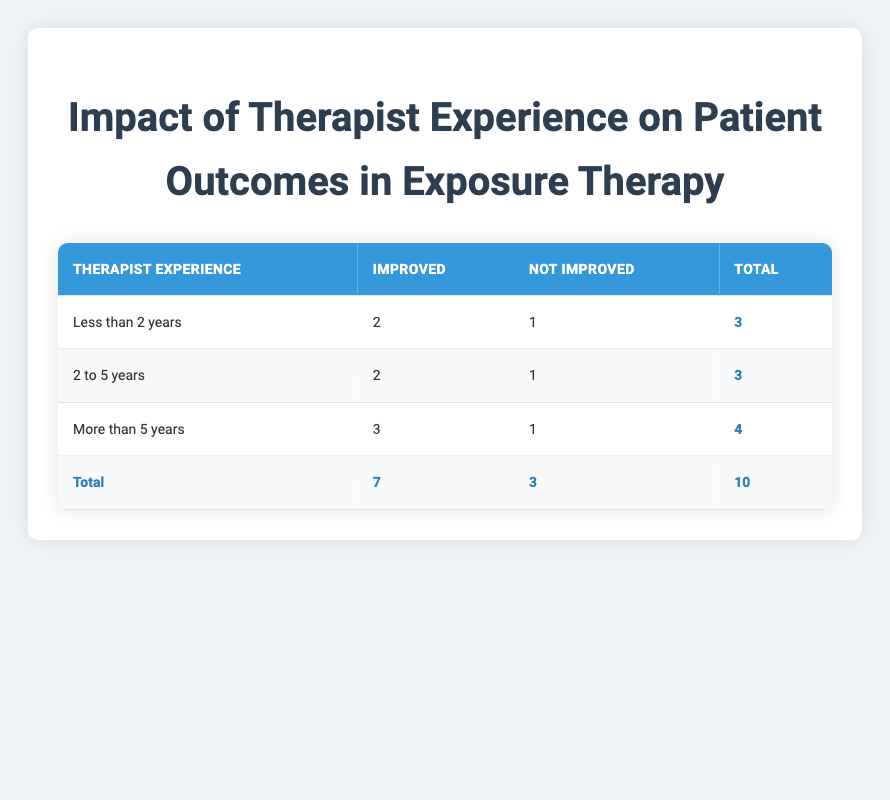What is the total number of patients treated by therapists with less than 2 years of experience? From the table, for therapists with less than 2 years of experience, there are 2 Improved outcomes and 1 Not Improved outcome. Adding these gives a total of 2 + 1 = 3 patients.
Answer: 3 How many patients improved when treated by therapists with more than 5 years of experience? The table shows that for therapists with more than 5 years of experience, there are 3 Improved outcomes. Therefore, the number of patients who improved is 3.
Answer: 3 What is the ratio of Improved to Not Improved outcomes for therapists with 2 to 5 years of experience? According to the table, therapists with 2 to 5 years of experience have 2 Improved outcomes and 1 Not Improved outcome. The ratio is 2:1, which means for every 2 patients who improved, there is 1 patient who did not improve.
Answer: 2:1 Is the statement "Patients treated by therapists for more than 5 years have more improved outcomes than those treated by therapists with less than 2 years" true? By analyzing the table, therapists with more than 5 years of experience had 3 Improved outcomes whereas those with less than 2 years had 2 Improved outcomes. Therefore, the statement is true because 3 is greater than 2.
Answer: Yes What percentage of the total sessions resulted in improved outcomes across all experience groups? First, we need to find the total number of improved outcomes, which is 7. The total sessions recorded in the table are 10. The percentage of improved outcomes is calculated as (7/10) * 100 = 70%.
Answer: 70% 